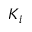<formula> <loc_0><loc_0><loc_500><loc_500>K _ { i }</formula> 